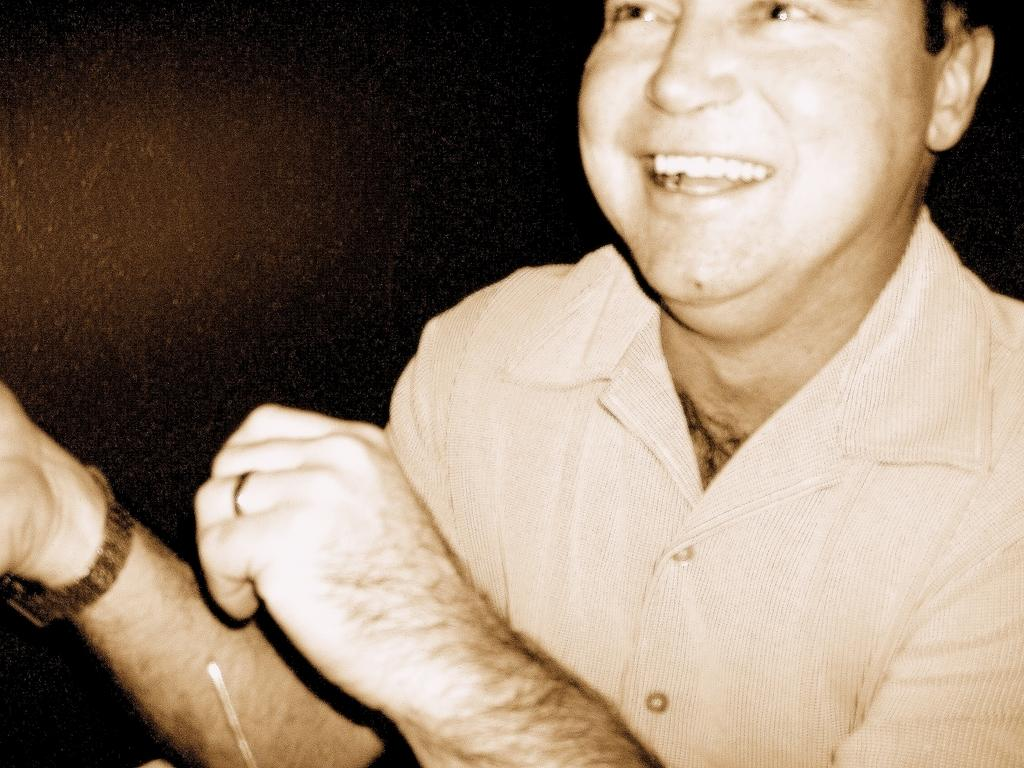What is the main subject of the image? The main subject of the image is a man. What is the man wearing in the image? The man is wearing a shirt in the image. What is the man's facial expression in the image? The man is smiling in the image. What accessories does the man have in the image? The man has a watch and a finger ring in the image. How would you describe the backdrop of the image? The backdrop of the image is dark. What type of chicken can be seen on the man's vacation? There is no chicken or vacation mentioned or depicted in the image. 